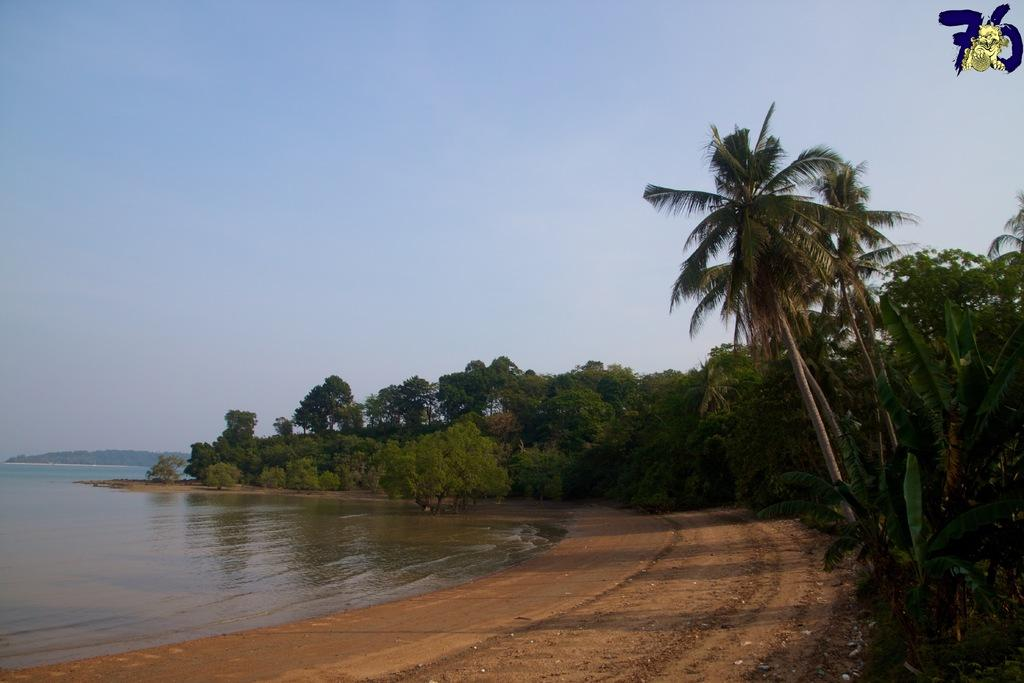What is present in the image that is not solid? There is water in the image. What type of natural vegetation can be seen in the image? There are trees in the image. What can be seen in the distance in the image? The sky is visible in the background of the image. Is there any indication of the image's origin or ownership? Yes, there is a watermark on the image. What type of crime is being committed in the image? There is no indication of any crime being committed in the image. What scientific experiment is being conducted in the image? There is no scientific experiment visible in the image. 